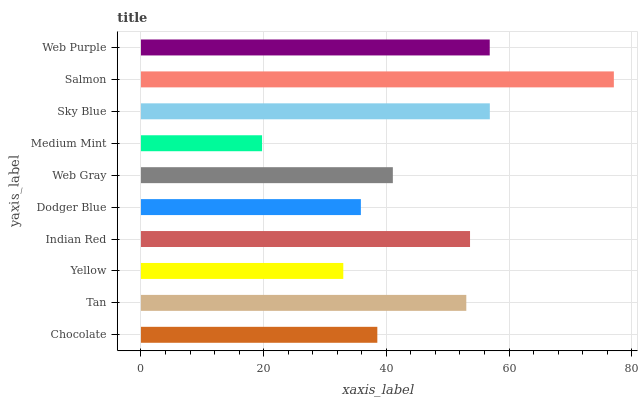Is Medium Mint the minimum?
Answer yes or no. Yes. Is Salmon the maximum?
Answer yes or no. Yes. Is Tan the minimum?
Answer yes or no. No. Is Tan the maximum?
Answer yes or no. No. Is Tan greater than Chocolate?
Answer yes or no. Yes. Is Chocolate less than Tan?
Answer yes or no. Yes. Is Chocolate greater than Tan?
Answer yes or no. No. Is Tan less than Chocolate?
Answer yes or no. No. Is Tan the high median?
Answer yes or no. Yes. Is Web Gray the low median?
Answer yes or no. Yes. Is Indian Red the high median?
Answer yes or no. No. Is Indian Red the low median?
Answer yes or no. No. 